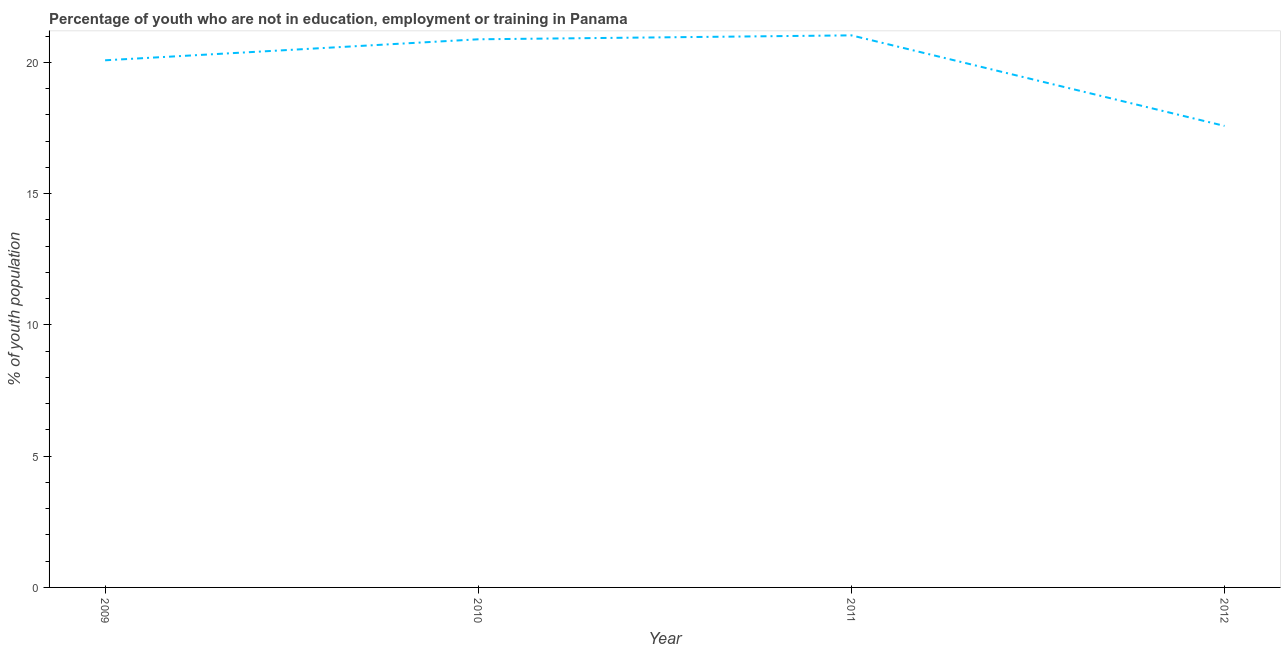What is the unemployed youth population in 2010?
Provide a short and direct response. 20.88. Across all years, what is the maximum unemployed youth population?
Your answer should be compact. 21.03. Across all years, what is the minimum unemployed youth population?
Ensure brevity in your answer.  17.58. In which year was the unemployed youth population minimum?
Provide a short and direct response. 2012. What is the sum of the unemployed youth population?
Your answer should be compact. 79.57. What is the difference between the unemployed youth population in 2011 and 2012?
Give a very brief answer. 3.45. What is the average unemployed youth population per year?
Provide a succinct answer. 19.89. What is the median unemployed youth population?
Ensure brevity in your answer.  20.48. In how many years, is the unemployed youth population greater than 6 %?
Your answer should be very brief. 4. What is the ratio of the unemployed youth population in 2010 to that in 2012?
Your response must be concise. 1.19. Is the difference between the unemployed youth population in 2009 and 2010 greater than the difference between any two years?
Your answer should be very brief. No. What is the difference between the highest and the second highest unemployed youth population?
Ensure brevity in your answer.  0.15. What is the difference between the highest and the lowest unemployed youth population?
Provide a short and direct response. 3.45. In how many years, is the unemployed youth population greater than the average unemployed youth population taken over all years?
Provide a short and direct response. 3. Does the unemployed youth population monotonically increase over the years?
Give a very brief answer. No. How many years are there in the graph?
Your answer should be compact. 4. What is the difference between two consecutive major ticks on the Y-axis?
Make the answer very short. 5. Are the values on the major ticks of Y-axis written in scientific E-notation?
Your response must be concise. No. Does the graph contain grids?
Offer a very short reply. No. What is the title of the graph?
Give a very brief answer. Percentage of youth who are not in education, employment or training in Panama. What is the label or title of the Y-axis?
Your answer should be very brief. % of youth population. What is the % of youth population of 2009?
Provide a short and direct response. 20.08. What is the % of youth population in 2010?
Keep it short and to the point. 20.88. What is the % of youth population of 2011?
Provide a succinct answer. 21.03. What is the % of youth population in 2012?
Provide a short and direct response. 17.58. What is the difference between the % of youth population in 2009 and 2010?
Your answer should be very brief. -0.8. What is the difference between the % of youth population in 2009 and 2011?
Provide a succinct answer. -0.95. What is the difference between the % of youth population in 2009 and 2012?
Ensure brevity in your answer.  2.5. What is the difference between the % of youth population in 2010 and 2011?
Offer a terse response. -0.15. What is the difference between the % of youth population in 2010 and 2012?
Offer a very short reply. 3.3. What is the difference between the % of youth population in 2011 and 2012?
Offer a very short reply. 3.45. What is the ratio of the % of youth population in 2009 to that in 2011?
Your answer should be very brief. 0.95. What is the ratio of the % of youth population in 2009 to that in 2012?
Provide a succinct answer. 1.14. What is the ratio of the % of youth population in 2010 to that in 2012?
Provide a succinct answer. 1.19. What is the ratio of the % of youth population in 2011 to that in 2012?
Give a very brief answer. 1.2. 